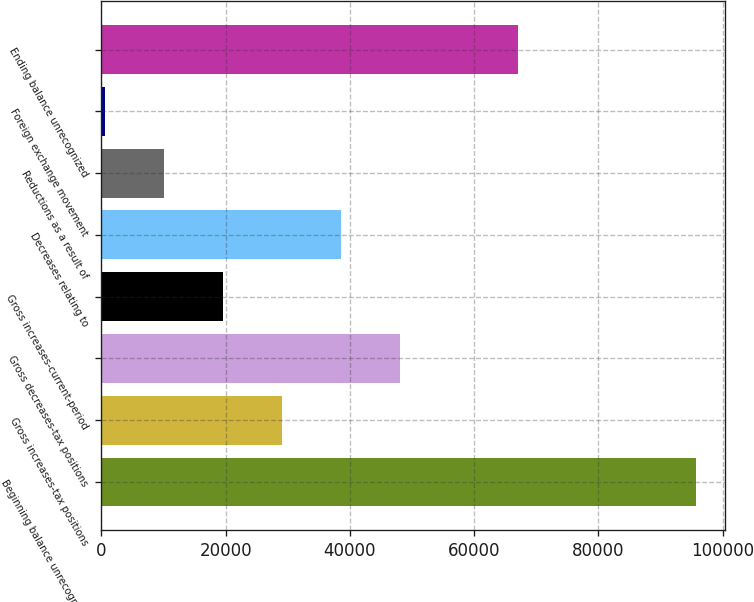<chart> <loc_0><loc_0><loc_500><loc_500><bar_chart><fcel>Beginning balance unrecognized<fcel>Gross increases-tax positions<fcel>Gross decreases-tax positions<fcel>Gross increases-current-period<fcel>Decreases relating to<fcel>Reductions as a result of<fcel>Foreign exchange movement<fcel>Ending balance unrecognized<nl><fcel>95664<fcel>29082.8<fcel>48106<fcel>19571.2<fcel>38594.4<fcel>10059.6<fcel>548<fcel>66984<nl></chart> 